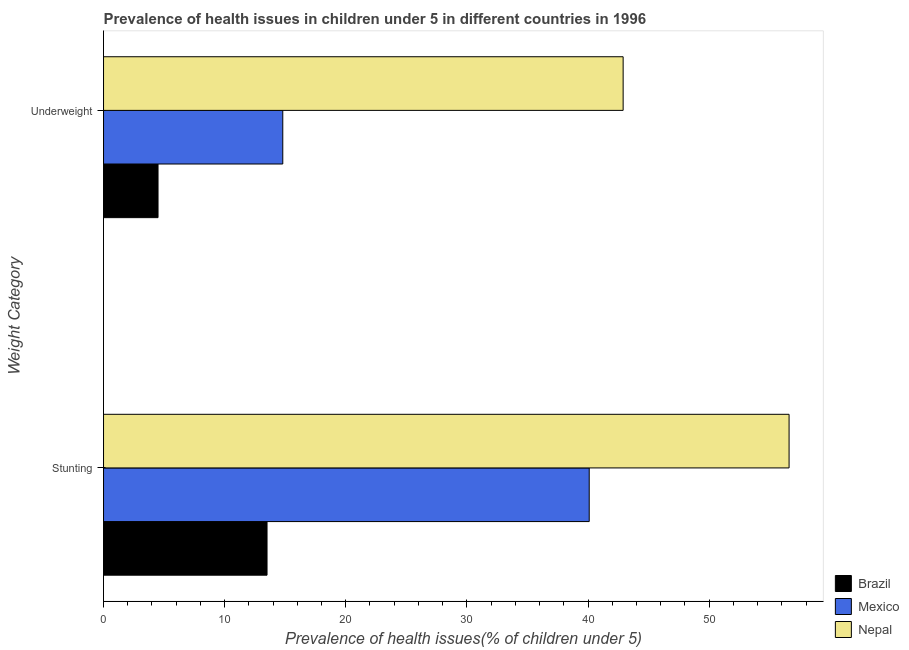How many different coloured bars are there?
Offer a very short reply. 3. How many groups of bars are there?
Provide a succinct answer. 2. Are the number of bars per tick equal to the number of legend labels?
Offer a very short reply. Yes. How many bars are there on the 1st tick from the top?
Give a very brief answer. 3. What is the label of the 2nd group of bars from the top?
Offer a terse response. Stunting. What is the percentage of stunted children in Brazil?
Ensure brevity in your answer.  13.5. Across all countries, what is the maximum percentage of underweight children?
Provide a succinct answer. 42.9. Across all countries, what is the minimum percentage of underweight children?
Keep it short and to the point. 4.5. In which country was the percentage of underweight children maximum?
Your answer should be very brief. Nepal. In which country was the percentage of underweight children minimum?
Offer a very short reply. Brazil. What is the total percentage of stunted children in the graph?
Make the answer very short. 110.2. What is the difference between the percentage of stunted children in Nepal and that in Brazil?
Your answer should be compact. 43.1. What is the difference between the percentage of underweight children in Mexico and the percentage of stunted children in Nepal?
Keep it short and to the point. -41.8. What is the average percentage of stunted children per country?
Provide a short and direct response. 36.73. What is the difference between the percentage of underweight children and percentage of stunted children in Nepal?
Your answer should be compact. -13.7. What is the ratio of the percentage of underweight children in Mexico to that in Brazil?
Offer a terse response. 3.29. Is the percentage of underweight children in Nepal less than that in Brazil?
Your answer should be compact. No. What does the 3rd bar from the bottom in Stunting represents?
Keep it short and to the point. Nepal. How many bars are there?
Make the answer very short. 6. Are all the bars in the graph horizontal?
Your answer should be very brief. Yes. How many countries are there in the graph?
Provide a short and direct response. 3. Does the graph contain grids?
Provide a short and direct response. No. Where does the legend appear in the graph?
Your response must be concise. Bottom right. How are the legend labels stacked?
Your answer should be very brief. Vertical. What is the title of the graph?
Make the answer very short. Prevalence of health issues in children under 5 in different countries in 1996. What is the label or title of the X-axis?
Your answer should be compact. Prevalence of health issues(% of children under 5). What is the label or title of the Y-axis?
Make the answer very short. Weight Category. What is the Prevalence of health issues(% of children under 5) of Mexico in Stunting?
Ensure brevity in your answer.  40.1. What is the Prevalence of health issues(% of children under 5) in Nepal in Stunting?
Your answer should be compact. 56.6. What is the Prevalence of health issues(% of children under 5) in Mexico in Underweight?
Give a very brief answer. 14.8. What is the Prevalence of health issues(% of children under 5) of Nepal in Underweight?
Provide a succinct answer. 42.9. Across all Weight Category, what is the maximum Prevalence of health issues(% of children under 5) of Brazil?
Give a very brief answer. 13.5. Across all Weight Category, what is the maximum Prevalence of health issues(% of children under 5) of Mexico?
Provide a short and direct response. 40.1. Across all Weight Category, what is the maximum Prevalence of health issues(% of children under 5) in Nepal?
Offer a terse response. 56.6. Across all Weight Category, what is the minimum Prevalence of health issues(% of children under 5) of Mexico?
Give a very brief answer. 14.8. Across all Weight Category, what is the minimum Prevalence of health issues(% of children under 5) of Nepal?
Provide a short and direct response. 42.9. What is the total Prevalence of health issues(% of children under 5) in Brazil in the graph?
Your response must be concise. 18. What is the total Prevalence of health issues(% of children under 5) of Mexico in the graph?
Offer a very short reply. 54.9. What is the total Prevalence of health issues(% of children under 5) in Nepal in the graph?
Give a very brief answer. 99.5. What is the difference between the Prevalence of health issues(% of children under 5) of Brazil in Stunting and that in Underweight?
Provide a succinct answer. 9. What is the difference between the Prevalence of health issues(% of children under 5) of Mexico in Stunting and that in Underweight?
Ensure brevity in your answer.  25.3. What is the difference between the Prevalence of health issues(% of children under 5) of Nepal in Stunting and that in Underweight?
Ensure brevity in your answer.  13.7. What is the difference between the Prevalence of health issues(% of children under 5) in Brazil in Stunting and the Prevalence of health issues(% of children under 5) in Nepal in Underweight?
Make the answer very short. -29.4. What is the average Prevalence of health issues(% of children under 5) of Brazil per Weight Category?
Your answer should be very brief. 9. What is the average Prevalence of health issues(% of children under 5) in Mexico per Weight Category?
Make the answer very short. 27.45. What is the average Prevalence of health issues(% of children under 5) of Nepal per Weight Category?
Give a very brief answer. 49.75. What is the difference between the Prevalence of health issues(% of children under 5) of Brazil and Prevalence of health issues(% of children under 5) of Mexico in Stunting?
Offer a terse response. -26.6. What is the difference between the Prevalence of health issues(% of children under 5) in Brazil and Prevalence of health issues(% of children under 5) in Nepal in Stunting?
Your answer should be very brief. -43.1. What is the difference between the Prevalence of health issues(% of children under 5) of Mexico and Prevalence of health issues(% of children under 5) of Nepal in Stunting?
Your answer should be compact. -16.5. What is the difference between the Prevalence of health issues(% of children under 5) in Brazil and Prevalence of health issues(% of children under 5) in Mexico in Underweight?
Your answer should be compact. -10.3. What is the difference between the Prevalence of health issues(% of children under 5) in Brazil and Prevalence of health issues(% of children under 5) in Nepal in Underweight?
Give a very brief answer. -38.4. What is the difference between the Prevalence of health issues(% of children under 5) in Mexico and Prevalence of health issues(% of children under 5) in Nepal in Underweight?
Provide a short and direct response. -28.1. What is the ratio of the Prevalence of health issues(% of children under 5) of Brazil in Stunting to that in Underweight?
Make the answer very short. 3. What is the ratio of the Prevalence of health issues(% of children under 5) in Mexico in Stunting to that in Underweight?
Your answer should be compact. 2.71. What is the ratio of the Prevalence of health issues(% of children under 5) of Nepal in Stunting to that in Underweight?
Give a very brief answer. 1.32. What is the difference between the highest and the second highest Prevalence of health issues(% of children under 5) of Mexico?
Provide a short and direct response. 25.3. What is the difference between the highest and the lowest Prevalence of health issues(% of children under 5) of Brazil?
Ensure brevity in your answer.  9. What is the difference between the highest and the lowest Prevalence of health issues(% of children under 5) of Mexico?
Offer a very short reply. 25.3. 